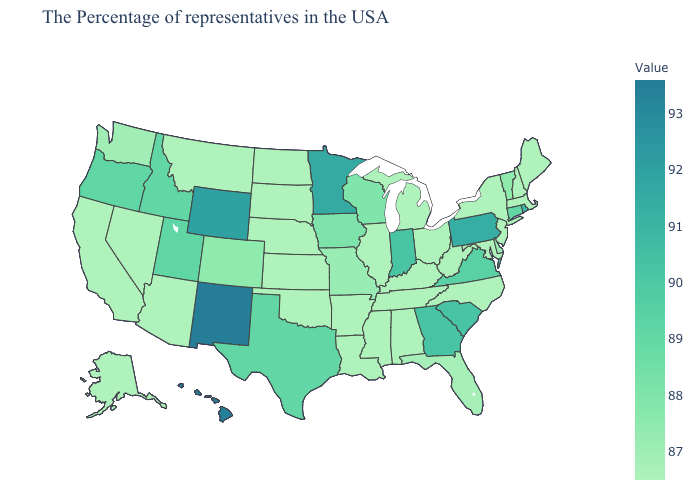Which states have the lowest value in the USA?
Write a very short answer. Maine, Massachusetts, New Hampshire, New York, New Jersey, Maryland, North Carolina, West Virginia, Ohio, Michigan, Kentucky, Alabama, Tennessee, Illinois, Mississippi, Louisiana, Arkansas, Kansas, Nebraska, Oklahoma, South Dakota, North Dakota, Montana, Arizona, Nevada, California, Alaska. Does Connecticut have the highest value in the USA?
Quick response, please. No. Among the states that border Maryland , does Virginia have the lowest value?
Quick response, please. No. Which states have the highest value in the USA?
Answer briefly. New Mexico. Does Georgia have the lowest value in the USA?
Short answer required. No. 